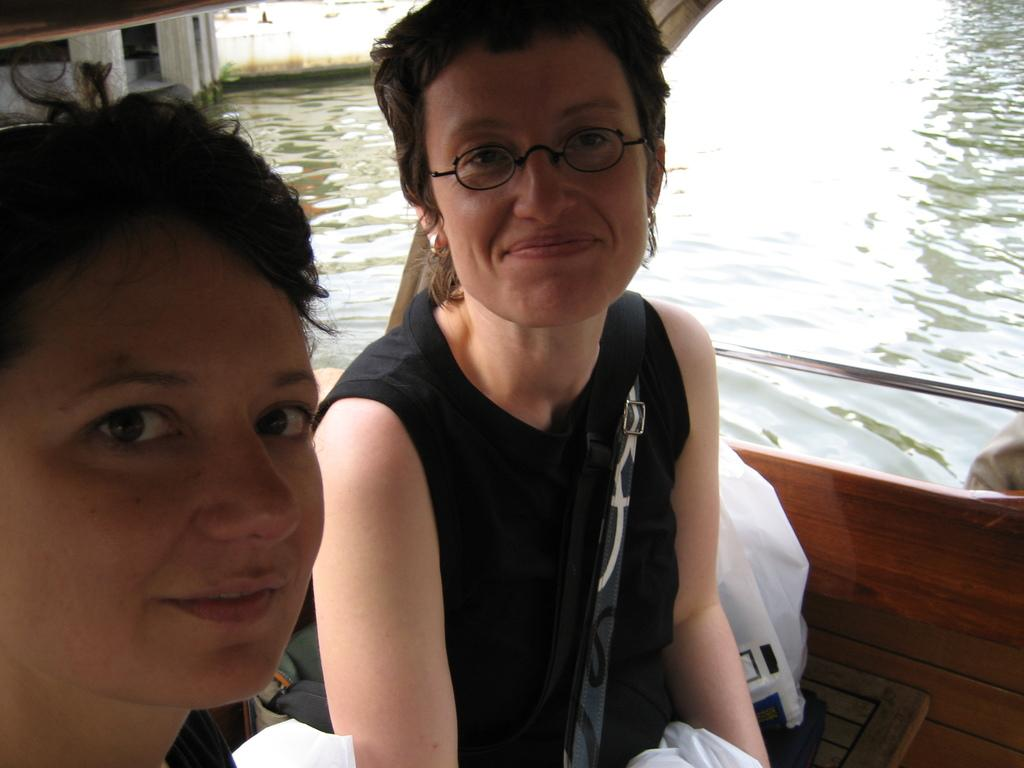How many people are in the image? There are two persons in the image. What are the persons doing in the image? The persons are sitting in a boat. What expression do the persons have in the image? The persons are smiling. What can be seen in the background of the image? There is water visible in the image. What type of tax is being discussed by the persons in the image? There is no indication in the image that the persons are discussing any taxes. 